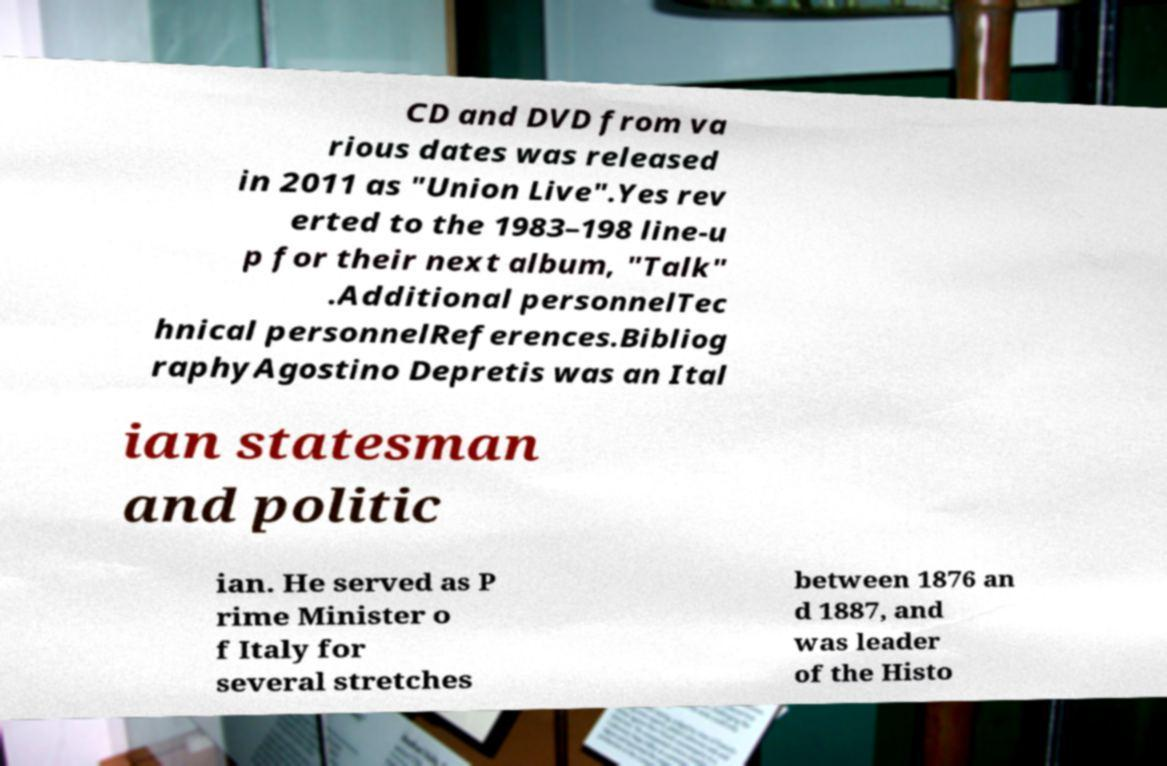Please identify and transcribe the text found in this image. CD and DVD from va rious dates was released in 2011 as "Union Live".Yes rev erted to the 1983–198 line-u p for their next album, "Talk" .Additional personnelTec hnical personnelReferences.Bibliog raphyAgostino Depretis was an Ital ian statesman and politic ian. He served as P rime Minister o f Italy for several stretches between 1876 an d 1887, and was leader of the Histo 